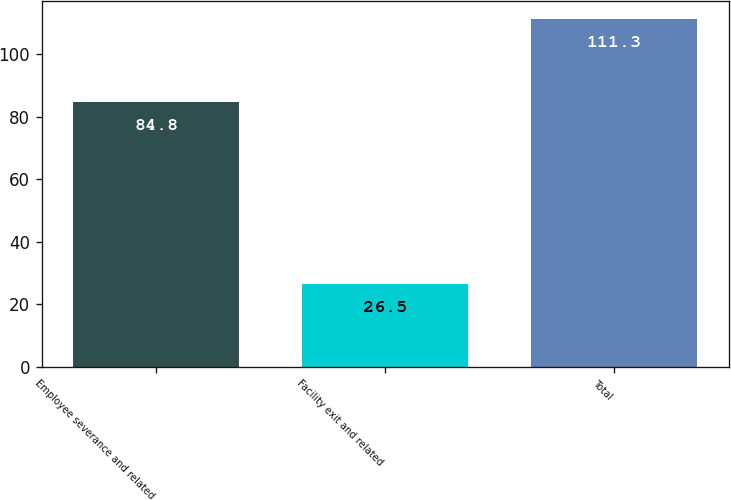Convert chart to OTSL. <chart><loc_0><loc_0><loc_500><loc_500><bar_chart><fcel>Employee severance and related<fcel>Facility exit and related<fcel>Total<nl><fcel>84.8<fcel>26.5<fcel>111.3<nl></chart> 